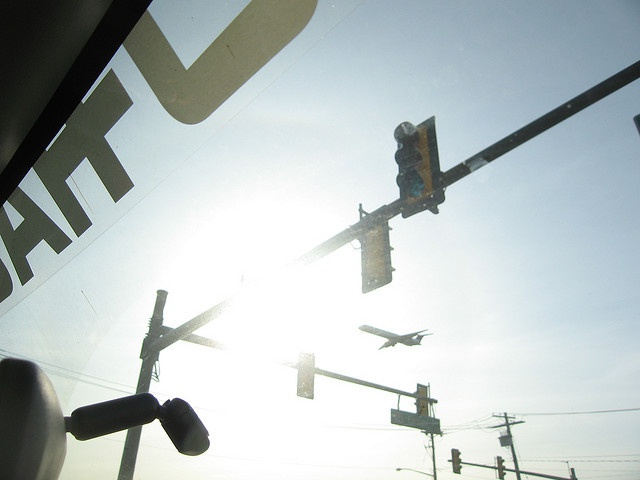Describe the objects in this image and their specific colors. I can see traffic light in black, darkgray, gray, and lightgray tones, traffic light in black, purple, and darkgray tones, traffic light in black, ivory, darkgray, and lightgray tones, airplane in black, darkgray, lightgray, and gray tones, and traffic light in black, gray, and darkgray tones in this image. 